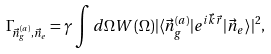Convert formula to latex. <formula><loc_0><loc_0><loc_500><loc_500>\Gamma _ { \vec { n } _ { g } ^ { ( a ) } , \vec { n } _ { e } } = \gamma \int d \Omega W ( \Omega ) | \langle \vec { n } _ { g } ^ { ( a ) } | e ^ { i \vec { k } \vec { r } } | \vec { n } _ { e } \rangle | ^ { 2 } ,</formula> 